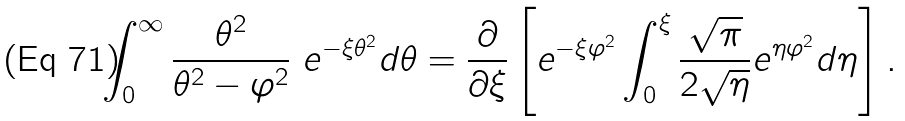<formula> <loc_0><loc_0><loc_500><loc_500>\int _ { 0 } ^ { \infty } \frac { \theta ^ { 2 } } { \theta ^ { 2 } - \varphi ^ { 2 } } \ e ^ { - \xi \theta ^ { 2 } } d \theta = \frac { \partial } { \partial \xi } \left [ e ^ { - \xi \varphi ^ { 2 } } \int _ { 0 } ^ { \xi } \frac { \sqrt { \pi } } { 2 \sqrt { \eta } } e ^ { \eta \varphi ^ { 2 } } d \eta \right ] .</formula> 